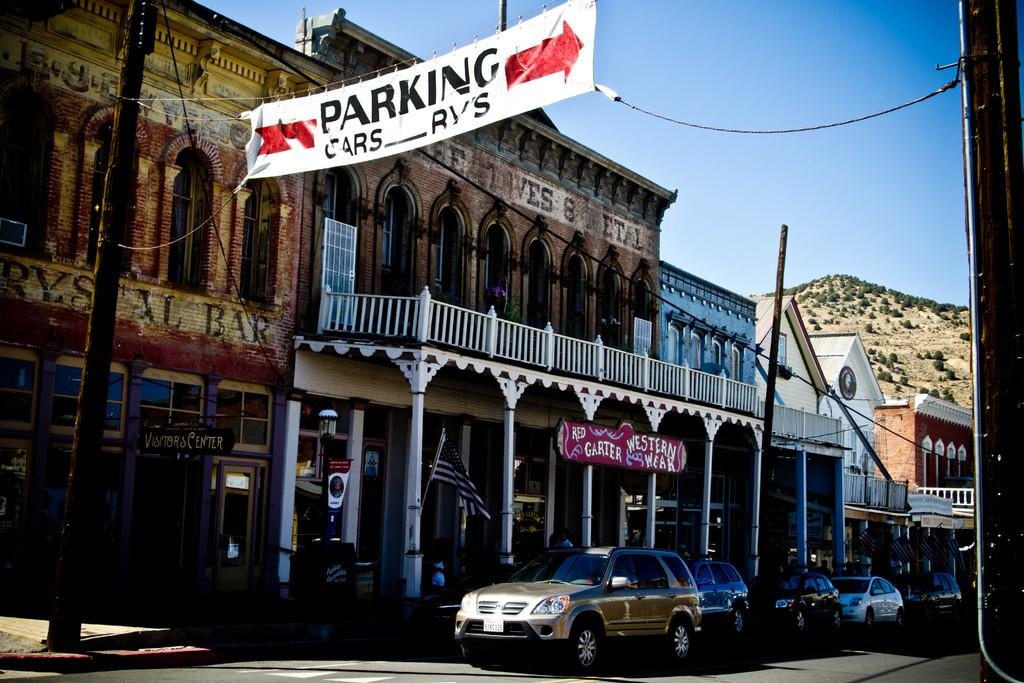<image>
Give a short and clear explanation of the subsequent image. A white banner hanging over a road points to parking. 